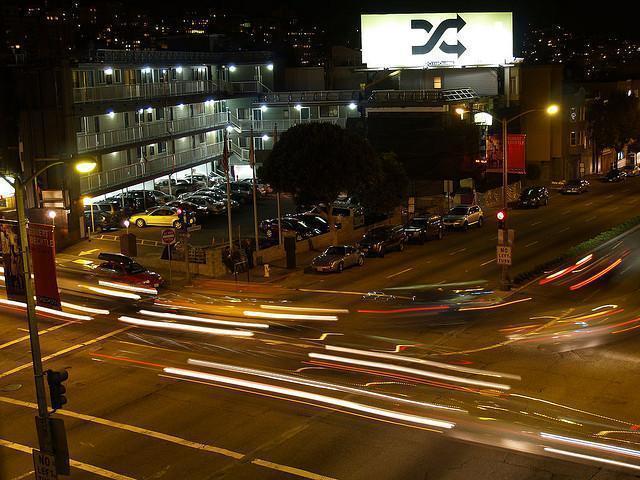What creates the colorful patterns on the ground?
From the following four choices, select the correct answer to address the question.
Options: Traffic, painting, thunder, street lamps. Traffic. 